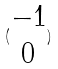<formula> <loc_0><loc_0><loc_500><loc_500>( \begin{matrix} - 1 \\ 0 \end{matrix} )</formula> 